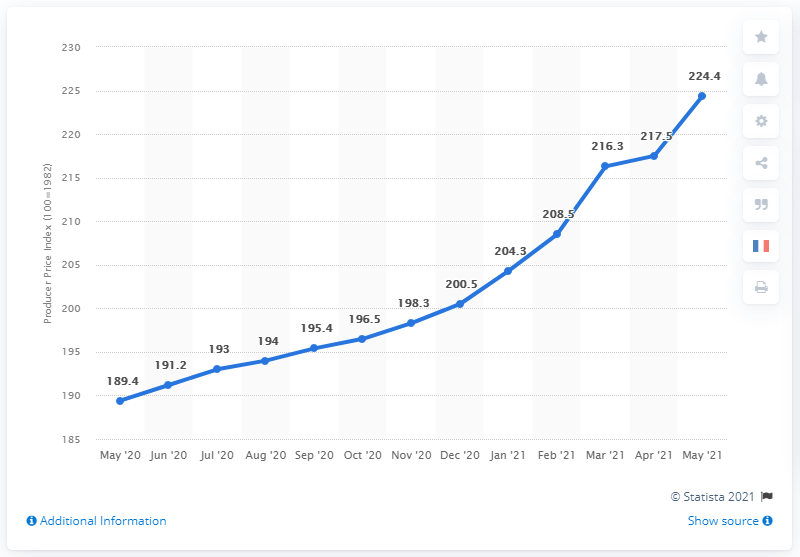Specify some key components in this picture. In May 2021, the Producer Price Index (PPI) for commodities in the United States was 224.4. The minimum Producer Price Index (PPI) for commodities in the United States was 189.4. The median value of the Producer Price Index (PPI) for commodities in the United States from May 2020 to May 2021 was 198.3. 